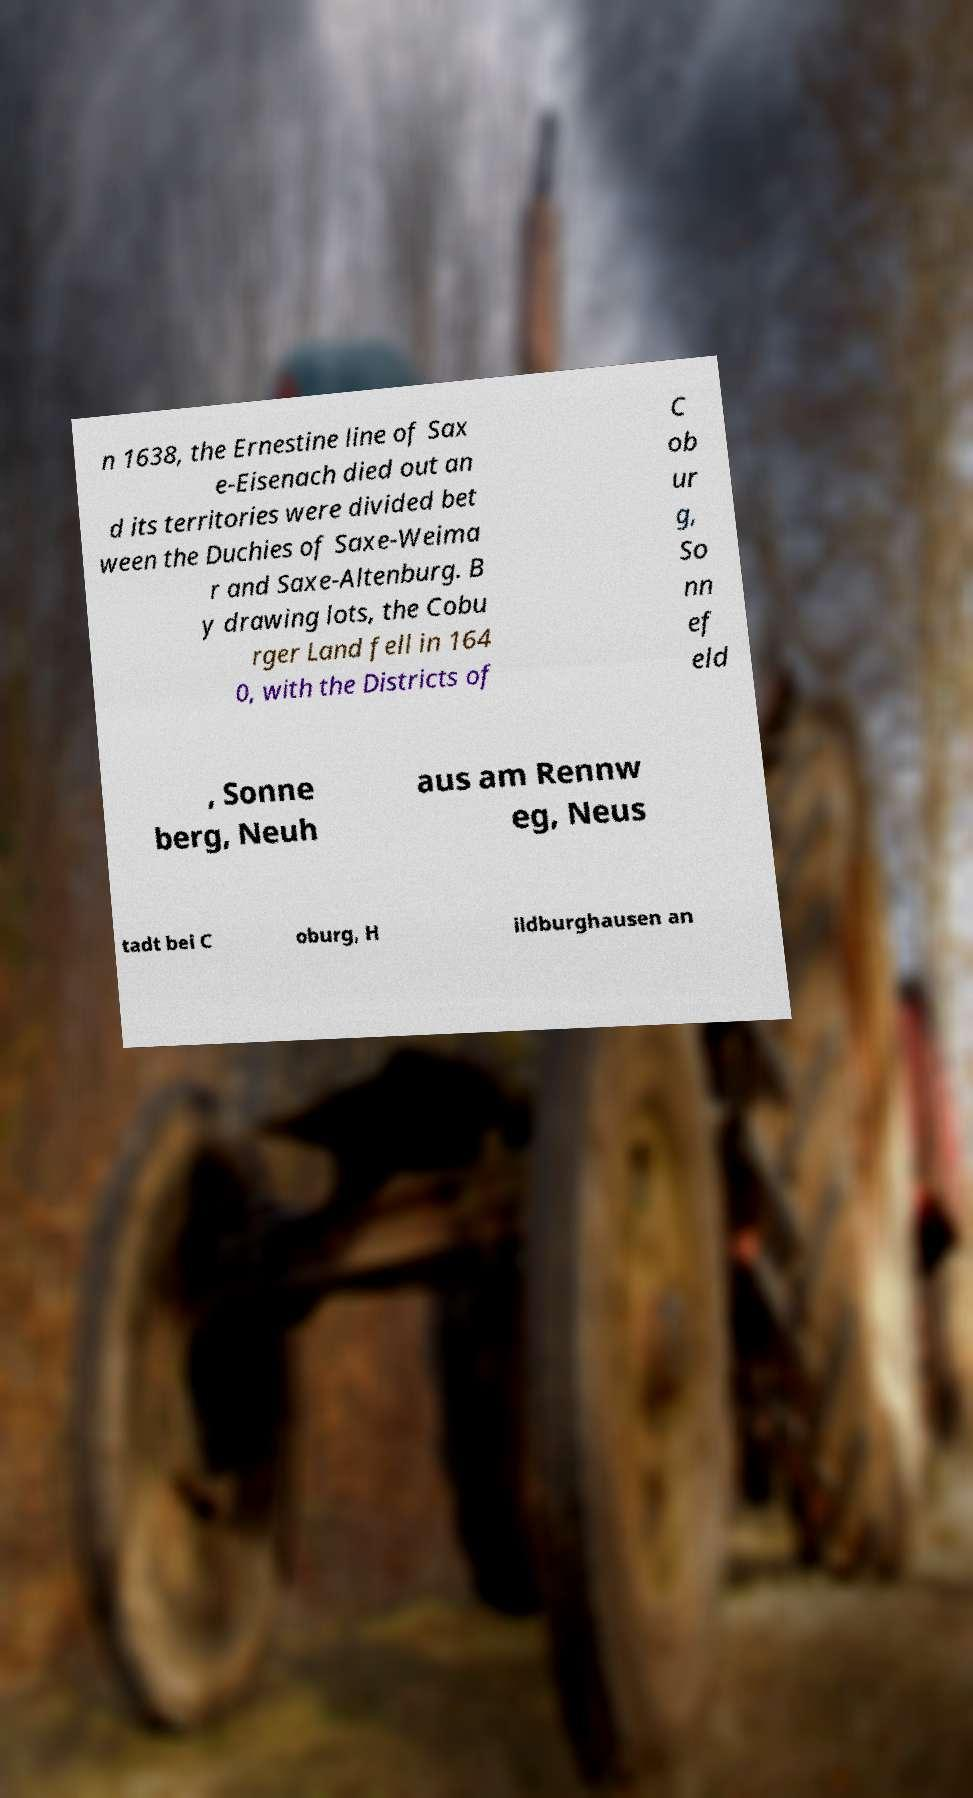Could you extract and type out the text from this image? n 1638, the Ernestine line of Sax e-Eisenach died out an d its territories were divided bet ween the Duchies of Saxe-Weima r and Saxe-Altenburg. B y drawing lots, the Cobu rger Land fell in 164 0, with the Districts of C ob ur g, So nn ef eld , Sonne berg, Neuh aus am Rennw eg, Neus tadt bei C oburg, H ildburghausen an 